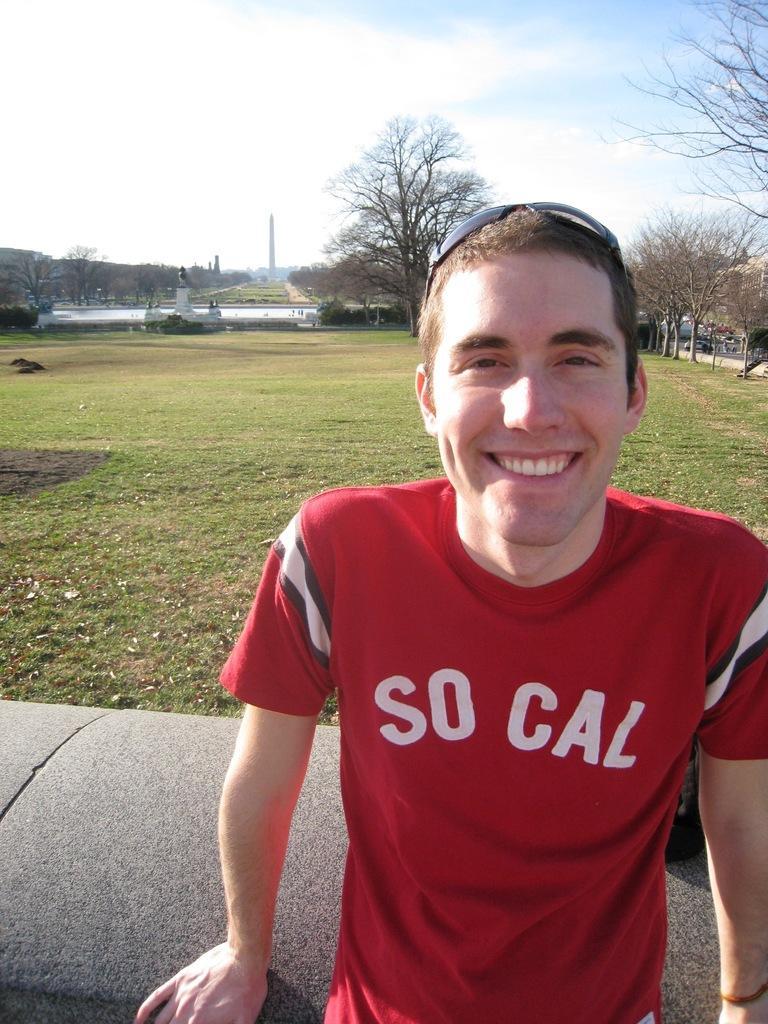In one or two sentences, can you explain what this image depicts? In this image we can see a man wearing the red color t shirt and also the glasses and smiling. In the background we can see the grass, trees, tower and also the sky with the clouds. 